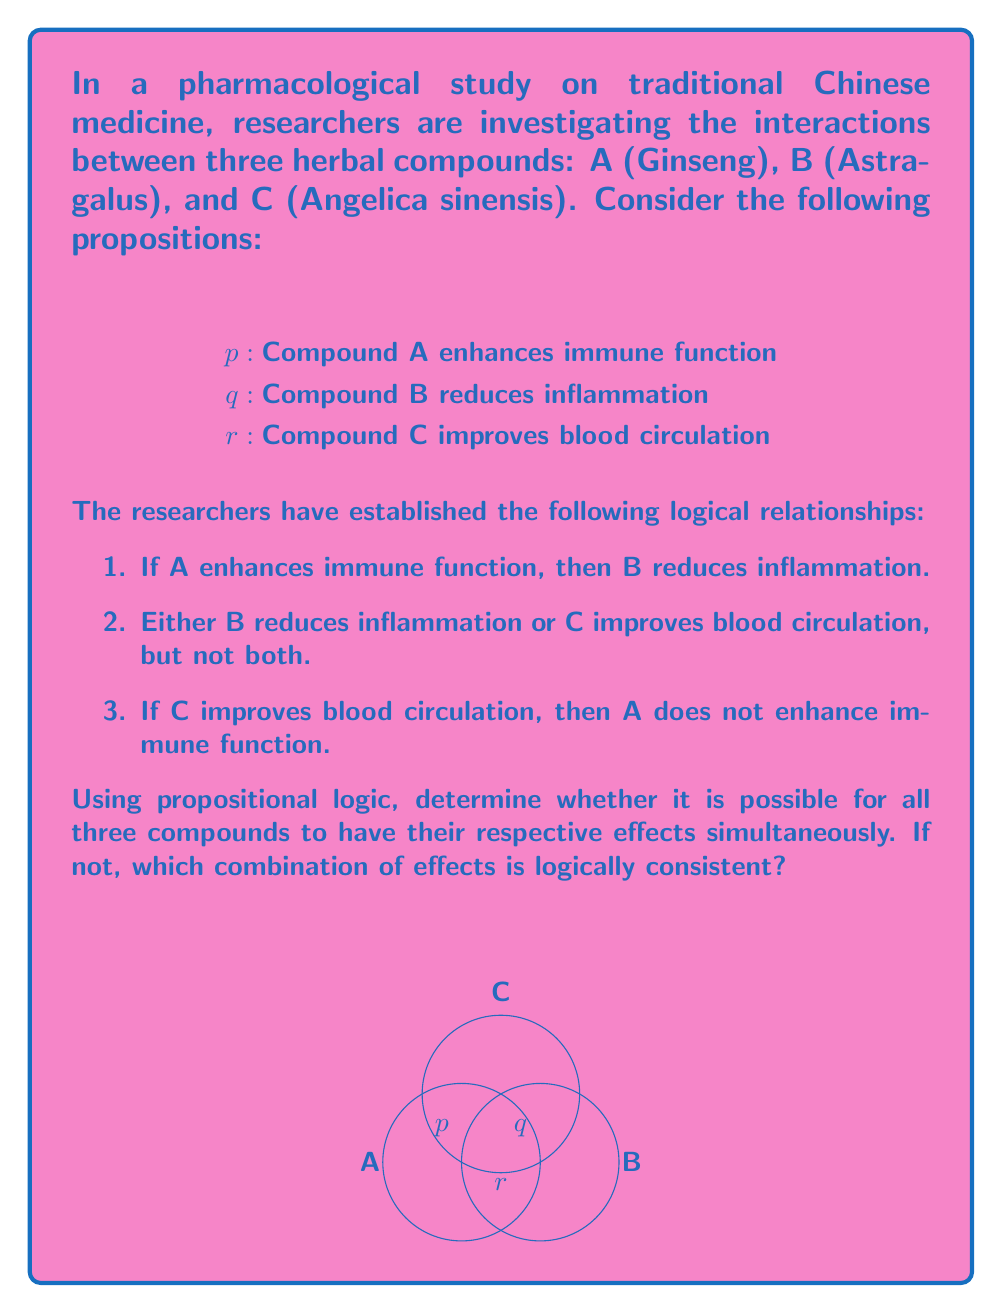Solve this math problem. Let's approach this step-by-step using propositional logic:

1) First, we translate the given relationships into logical expressions:
   a) $p \rightarrow q$
   b) $(q \wedge \neg r) \vee (\neg q \wedge r)$
   c) $r \rightarrow \neg p$

2) We want to determine if it's possible for all three propositions (p, q, and r) to be true simultaneously. Let's assume they are and see if we reach a contradiction.

3) If p is true, then by (a), q must be true.

4) If q is true, then by (b), r must be false (because q and r cannot both be true).

5) However, if p is true and r is false, this doesn't contradict (c), so we don't have a contradiction yet.

6) At this point, we have: p is true, q is true, and r is false. This satisfies all the given conditions:
   - It satisfies (a) because p implies q
   - It satisfies (b) because q is true and r is false
   - It satisfies (c) because r is false (so the implication is true regardless of p)

7) Therefore, it is logically consistent for compounds A and B to have their effects, but not C.

8) We can also check other combinations:
   - If only p is true: This violates (a)
   - If only q is true: This is consistent with all conditions
   - If only r is true: This is consistent with all conditions
   - If p and r are true: This violates (c)
   - If q and r are true: This violates (b)

9) In conclusion, there are three logically consistent combinations:
   - A enhances immune function and B reduces inflammation (p and q true, r false)
   - B reduces inflammation alone (only q true)
   - C improves blood circulation alone (only r true)
Answer: $\{p \wedge q \wedge \neg r\}$, $\{q\}$, $\{r\}$ 